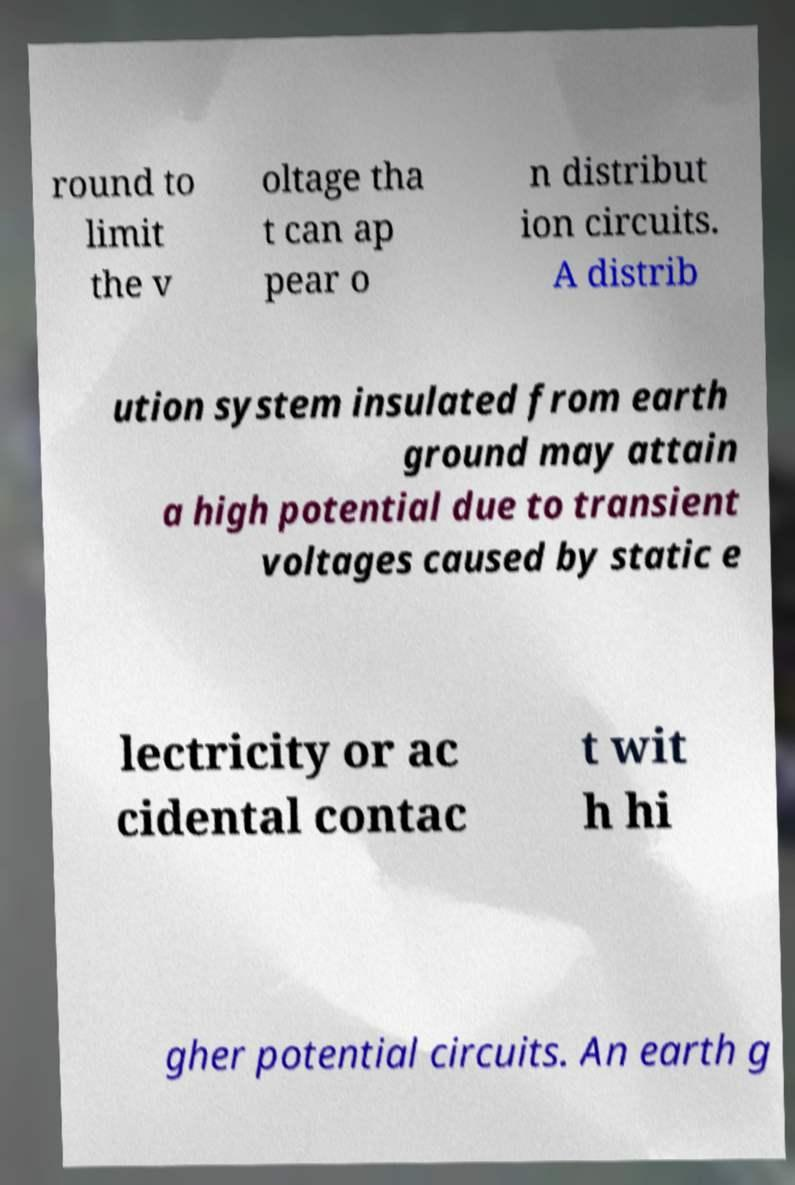What messages or text are displayed in this image? I need them in a readable, typed format. round to limit the v oltage tha t can ap pear o n distribut ion circuits. A distrib ution system insulated from earth ground may attain a high potential due to transient voltages caused by static e lectricity or ac cidental contac t wit h hi gher potential circuits. An earth g 